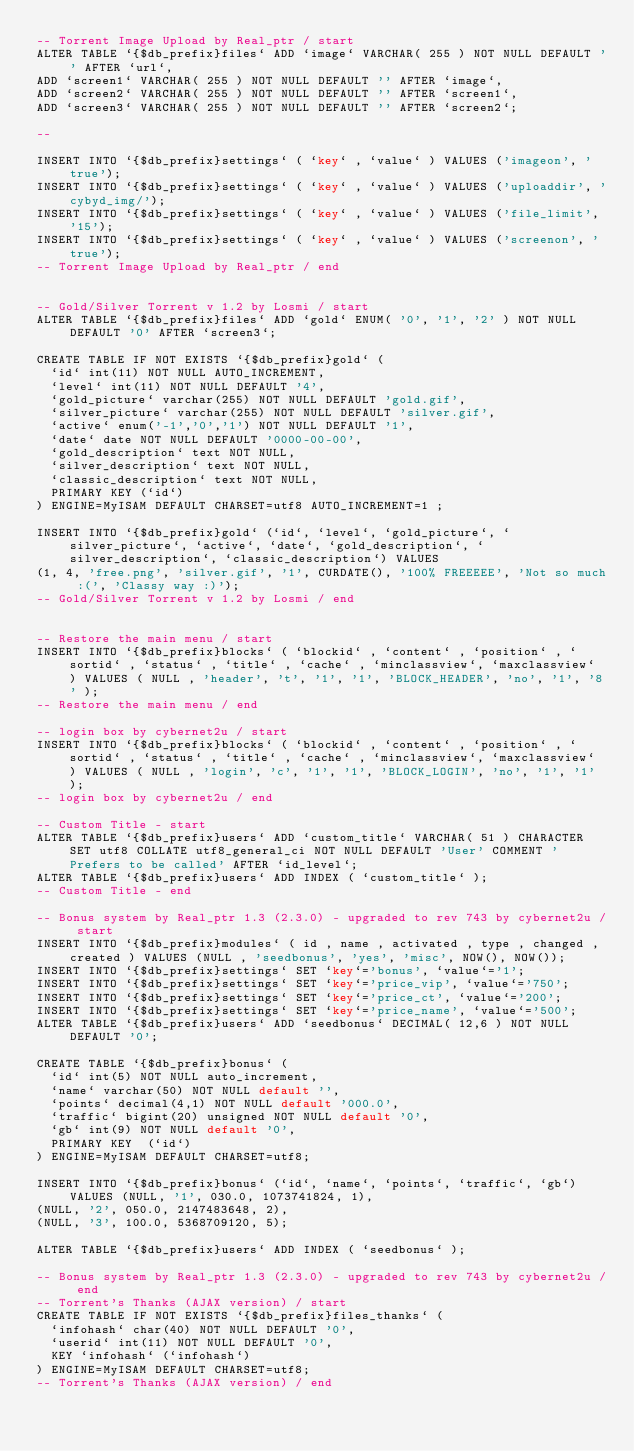Convert code to text. <code><loc_0><loc_0><loc_500><loc_500><_SQL_>-- Torrent Image Upload by Real_ptr / start
ALTER TABLE `{$db_prefix}files` ADD `image` VARCHAR( 255 ) NOT NULL DEFAULT '' AFTER `url`,
ADD `screen1` VARCHAR( 255 ) NOT NULL DEFAULT '' AFTER `image`,
ADD `screen2` VARCHAR( 255 ) NOT NULL DEFAULT '' AFTER `screen1`,
ADD `screen3` VARCHAR( 255 ) NOT NULL DEFAULT '' AFTER `screen2`;

--

INSERT INTO `{$db_prefix}settings` ( `key` , `value` ) VALUES ('imageon', 'true');
INSERT INTO `{$db_prefix}settings` ( `key` , `value` ) VALUES ('uploaddir', 'cybyd_img/');
INSERT INTO `{$db_prefix}settings` ( `key` , `value` ) VALUES ('file_limit', '15');
INSERT INTO `{$db_prefix}settings` ( `key` , `value` ) VALUES ('screenon', 'true');
-- Torrent Image Upload by Real_ptr / end


-- Gold/Silver Torrent v 1.2 by Losmi / start
ALTER TABLE `{$db_prefix}files` ADD `gold` ENUM( '0', '1', '2' ) NOT NULL DEFAULT '0' AFTER `screen3`;

CREATE TABLE IF NOT EXISTS `{$db_prefix}gold` (
  `id` int(11) NOT NULL AUTO_INCREMENT,
  `level` int(11) NOT NULL DEFAULT '4',
  `gold_picture` varchar(255) NOT NULL DEFAULT 'gold.gif',
  `silver_picture` varchar(255) NOT NULL DEFAULT 'silver.gif',
  `active` enum('-1','0','1') NOT NULL DEFAULT '1',
  `date` date NOT NULL DEFAULT '0000-00-00',
  `gold_description` text NOT NULL,
  `silver_description` text NOT NULL,
  `classic_description` text NOT NULL,
  PRIMARY KEY (`id`)
) ENGINE=MyISAM DEFAULT CHARSET=utf8 AUTO_INCREMENT=1 ;

INSERT INTO `{$db_prefix}gold` (`id`, `level`, `gold_picture`, `silver_picture`, `active`, `date`, `gold_description`, `silver_description`, `classic_description`) VALUES
(1, 4, 'free.png', 'silver.gif', '1', CURDATE(), '100% FREEEEE', 'Not so much :(', 'Classy way :)');
-- Gold/Silver Torrent v 1.2 by Losmi / end


-- Restore the main menu / start
INSERT INTO `{$db_prefix}blocks` ( `blockid` , `content` , `position` , `sortid` , `status` , `title` , `cache` , `minclassview`, `maxclassview` ) VALUES ( NULL , 'header', 't', '1', '1', 'BLOCK_HEADER', 'no', '1', '8' );
-- Restore the main menu / end

-- login box by cybernet2u / start
INSERT INTO `{$db_prefix}blocks` ( `blockid` , `content` , `position` , `sortid` , `status` , `title` , `cache` , `minclassview`, `maxclassview` ) VALUES ( NULL , 'login', 'c', '1', '1', 'BLOCK_LOGIN', 'no', '1', '1' );
-- login box by cybernet2u / end

-- Custom Title - start
ALTER TABLE `{$db_prefix}users` ADD `custom_title` VARCHAR( 51 ) CHARACTER SET utf8 COLLATE utf8_general_ci NOT NULL DEFAULT 'User' COMMENT 'Prefers to be called' AFTER `id_level`;
ALTER TABLE `{$db_prefix}users` ADD INDEX ( `custom_title` );
-- Custom Title - end

-- Bonus system by Real_ptr 1.3 (2.3.0) - upgraded to rev 743 by cybernet2u / start
INSERT INTO `{$db_prefix}modules` ( id , name , activated , type , changed , created ) VALUES (NULL , 'seedbonus', 'yes', 'misc', NOW(), NOW());
INSERT INTO `{$db_prefix}settings` SET `key`='bonus', `value`='1';
INSERT INTO `{$db_prefix}settings` SET `key`='price_vip', `value`='750';
INSERT INTO `{$db_prefix}settings` SET `key`='price_ct', `value`='200';
INSERT INTO `{$db_prefix}settings` SET `key`='price_name', `value`='500';
ALTER TABLE `{$db_prefix}users` ADD `seedbonus` DECIMAL( 12,6 ) NOT NULL DEFAULT '0';

CREATE TABLE `{$db_prefix}bonus` (
  `id` int(5) NOT NULL auto_increment,
  `name` varchar(50) NOT NULL default '',
  `points` decimal(4,1) NOT NULL default '000.0',
  `traffic` bigint(20) unsigned NOT NULL default '0',
  `gb` int(9) NOT NULL default '0',
  PRIMARY KEY  (`id`)
) ENGINE=MyISAM DEFAULT CHARSET=utf8;

INSERT INTO `{$db_prefix}bonus` (`id`, `name`, `points`, `traffic`, `gb`) VALUES (NULL, '1', 030.0, 1073741824, 1),
(NULL, '2', 050.0, 2147483648, 2),
(NULL, '3', 100.0, 5368709120, 5);

ALTER TABLE `{$db_prefix}users` ADD INDEX ( `seedbonus` );

-- Bonus system by Real_ptr 1.3 (2.3.0) - upgraded to rev 743 by cybernet2u / end
-- Torrent's Thanks (AJAX version) / start
CREATE TABLE IF NOT EXISTS `{$db_prefix}files_thanks` (
  `infohash` char(40) NOT NULL DEFAULT '0',
  `userid` int(11) NOT NULL DEFAULT '0',
  KEY `infohash` (`infohash`)
) ENGINE=MyISAM DEFAULT CHARSET=utf8;
-- Torrent's Thanks (AJAX version) / end
</code> 